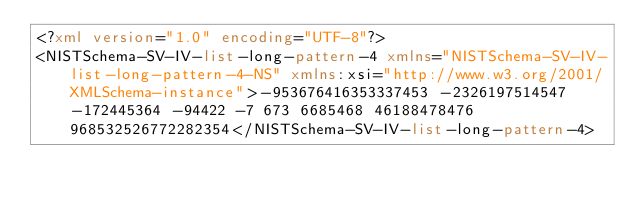<code> <loc_0><loc_0><loc_500><loc_500><_XML_><?xml version="1.0" encoding="UTF-8"?>
<NISTSchema-SV-IV-list-long-pattern-4 xmlns="NISTSchema-SV-IV-list-long-pattern-4-NS" xmlns:xsi="http://www.w3.org/2001/XMLSchema-instance">-953676416353337453 -2326197514547 -172445364 -94422 -7 673 6685468 46188478476 968532526772282354</NISTSchema-SV-IV-list-long-pattern-4>
</code> 